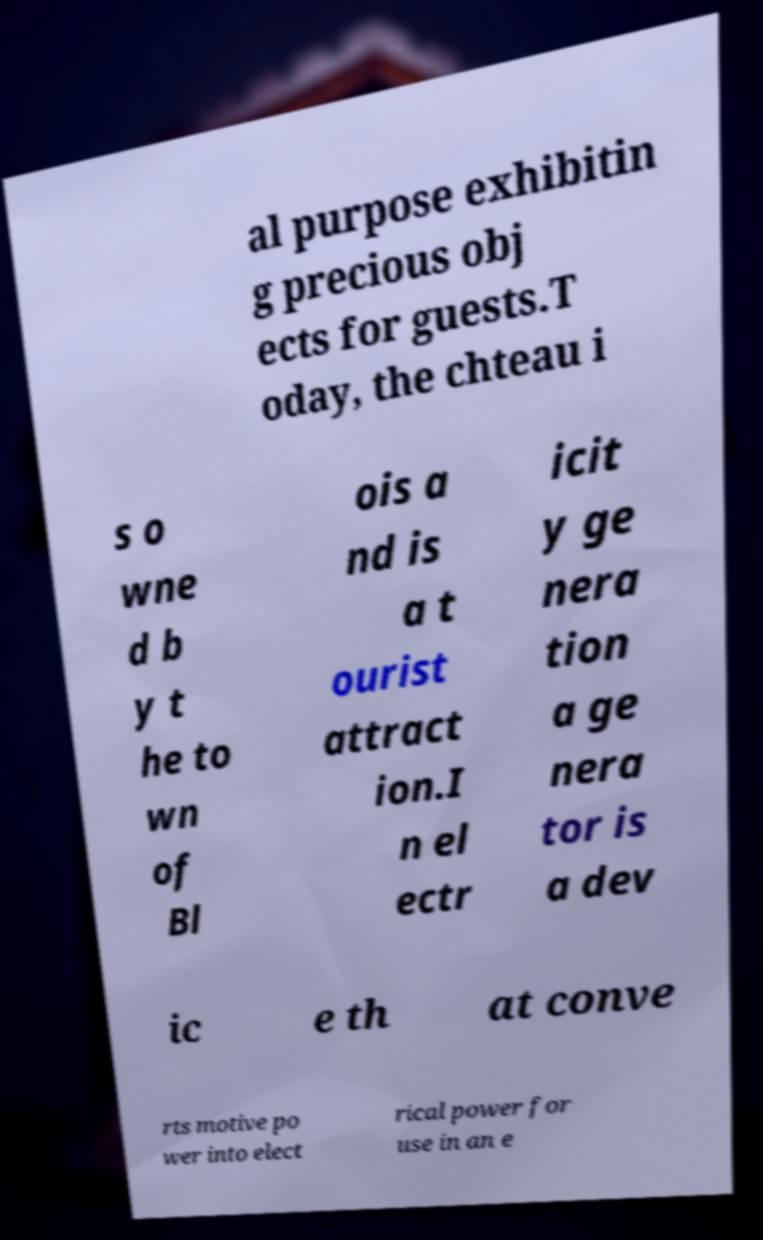Could you extract and type out the text from this image? al purpose exhibitin g precious obj ects for guests.T oday, the chteau i s o wne d b y t he to wn of Bl ois a nd is a t ourist attract ion.I n el ectr icit y ge nera tion a ge nera tor is a dev ic e th at conve rts motive po wer into elect rical power for use in an e 